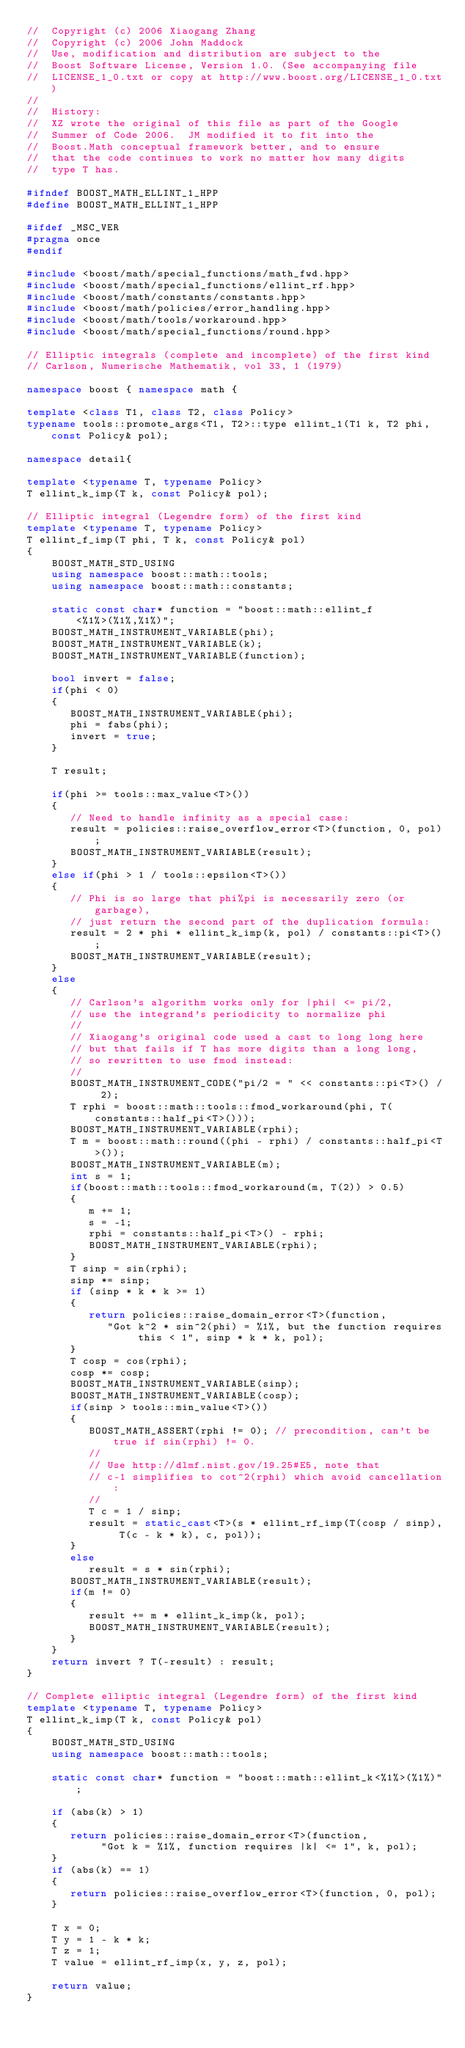<code> <loc_0><loc_0><loc_500><loc_500><_C++_>//  Copyright (c) 2006 Xiaogang Zhang
//  Copyright (c) 2006 John Maddock
//  Use, modification and distribution are subject to the
//  Boost Software License, Version 1.0. (See accompanying file
//  LICENSE_1_0.txt or copy at http://www.boost.org/LICENSE_1_0.txt)
//
//  History:
//  XZ wrote the original of this file as part of the Google
//  Summer of Code 2006.  JM modified it to fit into the
//  Boost.Math conceptual framework better, and to ensure
//  that the code continues to work no matter how many digits
//  type T has.

#ifndef BOOST_MATH_ELLINT_1_HPP
#define BOOST_MATH_ELLINT_1_HPP

#ifdef _MSC_VER
#pragma once
#endif

#include <boost/math/special_functions/math_fwd.hpp>
#include <boost/math/special_functions/ellint_rf.hpp>
#include <boost/math/constants/constants.hpp>
#include <boost/math/policies/error_handling.hpp>
#include <boost/math/tools/workaround.hpp>
#include <boost/math/special_functions/round.hpp>

// Elliptic integrals (complete and incomplete) of the first kind
// Carlson, Numerische Mathematik, vol 33, 1 (1979)

namespace boost { namespace math {

template <class T1, class T2, class Policy>
typename tools::promote_args<T1, T2>::type ellint_1(T1 k, T2 phi, const Policy& pol);

namespace detail{

template <typename T, typename Policy>
T ellint_k_imp(T k, const Policy& pol);

// Elliptic integral (Legendre form) of the first kind
template <typename T, typename Policy>
T ellint_f_imp(T phi, T k, const Policy& pol)
{
    BOOST_MATH_STD_USING
    using namespace boost::math::tools;
    using namespace boost::math::constants;

    static const char* function = "boost::math::ellint_f<%1%>(%1%,%1%)";
    BOOST_MATH_INSTRUMENT_VARIABLE(phi);
    BOOST_MATH_INSTRUMENT_VARIABLE(k);
    BOOST_MATH_INSTRUMENT_VARIABLE(function);

    bool invert = false;
    if(phi < 0)
    {
       BOOST_MATH_INSTRUMENT_VARIABLE(phi);
       phi = fabs(phi);
       invert = true;
    }

    T result;

    if(phi >= tools::max_value<T>())
    {
       // Need to handle infinity as a special case:
       result = policies::raise_overflow_error<T>(function, 0, pol);
       BOOST_MATH_INSTRUMENT_VARIABLE(result);
    }
    else if(phi > 1 / tools::epsilon<T>())
    {
       // Phi is so large that phi%pi is necessarily zero (or garbage),
       // just return the second part of the duplication formula:
       result = 2 * phi * ellint_k_imp(k, pol) / constants::pi<T>();
       BOOST_MATH_INSTRUMENT_VARIABLE(result);
    }
    else
    {
       // Carlson's algorithm works only for |phi| <= pi/2,
       // use the integrand's periodicity to normalize phi
       //
       // Xiaogang's original code used a cast to long long here
       // but that fails if T has more digits than a long long,
       // so rewritten to use fmod instead:
       //
       BOOST_MATH_INSTRUMENT_CODE("pi/2 = " << constants::pi<T>() / 2);
       T rphi = boost::math::tools::fmod_workaround(phi, T(constants::half_pi<T>()));
       BOOST_MATH_INSTRUMENT_VARIABLE(rphi);
       T m = boost::math::round((phi - rphi) / constants::half_pi<T>());
       BOOST_MATH_INSTRUMENT_VARIABLE(m);
       int s = 1;
       if(boost::math::tools::fmod_workaround(m, T(2)) > 0.5)
       {
          m += 1;
          s = -1;
          rphi = constants::half_pi<T>() - rphi;
          BOOST_MATH_INSTRUMENT_VARIABLE(rphi);
       }
       T sinp = sin(rphi);
       sinp *= sinp;
       if (sinp * k * k >= 1)
       {
          return policies::raise_domain_error<T>(function,
             "Got k^2 * sin^2(phi) = %1%, but the function requires this < 1", sinp * k * k, pol);
       }
       T cosp = cos(rphi);
       cosp *= cosp;
       BOOST_MATH_INSTRUMENT_VARIABLE(sinp);
       BOOST_MATH_INSTRUMENT_VARIABLE(cosp);
       if(sinp > tools::min_value<T>())
       {
          BOOST_MATH_ASSERT(rphi != 0); // precondition, can't be true if sin(rphi) != 0.
          //
          // Use http://dlmf.nist.gov/19.25#E5, note that
          // c-1 simplifies to cot^2(rphi) which avoid cancellation:
          //
          T c = 1 / sinp;
          result = static_cast<T>(s * ellint_rf_imp(T(cosp / sinp), T(c - k * k), c, pol));
       }
       else
          result = s * sin(rphi);
       BOOST_MATH_INSTRUMENT_VARIABLE(result);
       if(m != 0)
       {
          result += m * ellint_k_imp(k, pol);
          BOOST_MATH_INSTRUMENT_VARIABLE(result);
       }
    }
    return invert ? T(-result) : result;
}

// Complete elliptic integral (Legendre form) of the first kind
template <typename T, typename Policy>
T ellint_k_imp(T k, const Policy& pol)
{
    BOOST_MATH_STD_USING
    using namespace boost::math::tools;

    static const char* function = "boost::math::ellint_k<%1%>(%1%)";

    if (abs(k) > 1)
    {
       return policies::raise_domain_error<T>(function,
            "Got k = %1%, function requires |k| <= 1", k, pol);
    }
    if (abs(k) == 1)
    {
       return policies::raise_overflow_error<T>(function, 0, pol);
    }

    T x = 0;
    T y = 1 - k * k;
    T z = 1;
    T value = ellint_rf_imp(x, y, z, pol);

    return value;
}
</code> 